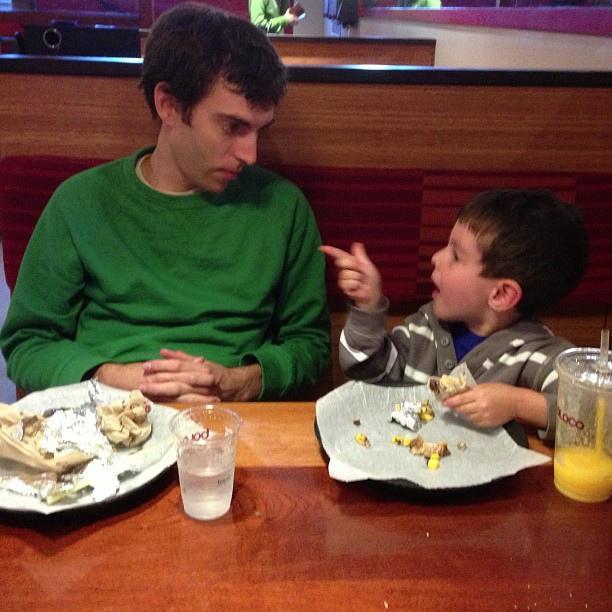How many cups can you see?
Give a very brief answer. 2. How many people are there?
Give a very brief answer. 2. How many people are on the elephant on the right?
Give a very brief answer. 0. 